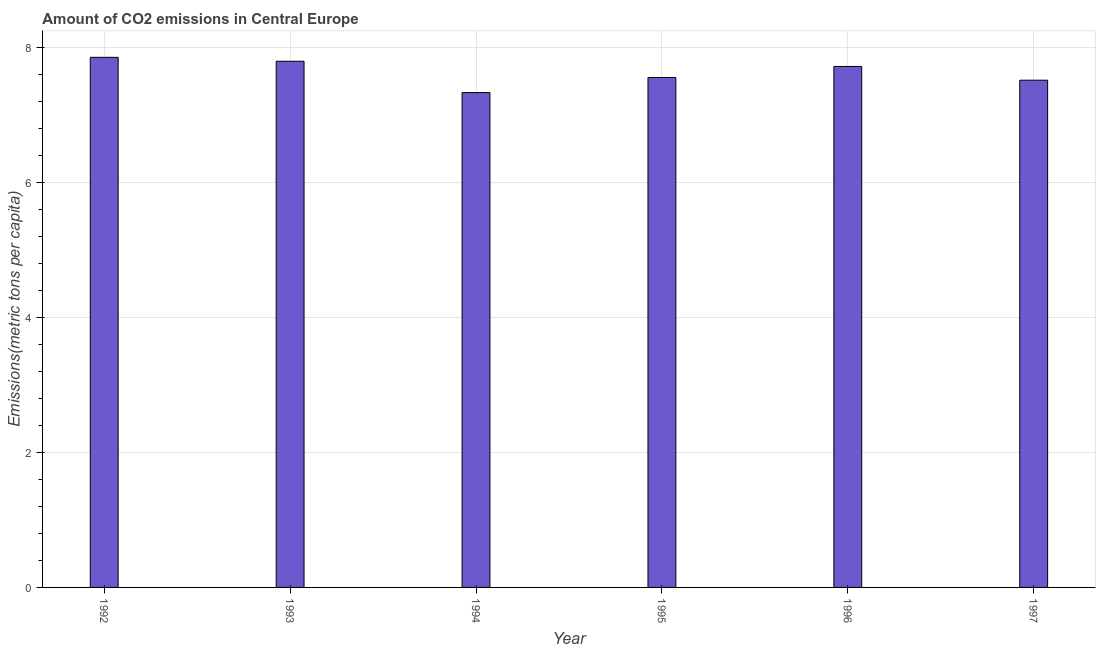Does the graph contain any zero values?
Provide a short and direct response. No. Does the graph contain grids?
Offer a very short reply. Yes. What is the title of the graph?
Your response must be concise. Amount of CO2 emissions in Central Europe. What is the label or title of the Y-axis?
Offer a terse response. Emissions(metric tons per capita). What is the amount of co2 emissions in 1993?
Provide a short and direct response. 7.79. Across all years, what is the maximum amount of co2 emissions?
Provide a succinct answer. 7.85. Across all years, what is the minimum amount of co2 emissions?
Offer a terse response. 7.33. What is the sum of the amount of co2 emissions?
Provide a succinct answer. 45.75. What is the difference between the amount of co2 emissions in 1993 and 1996?
Your answer should be very brief. 0.08. What is the average amount of co2 emissions per year?
Keep it short and to the point. 7.62. What is the median amount of co2 emissions?
Your answer should be very brief. 7.63. In how many years, is the amount of co2 emissions greater than 7.2 metric tons per capita?
Provide a short and direct response. 6. What is the ratio of the amount of co2 emissions in 1994 to that in 1995?
Provide a succinct answer. 0.97. Is the difference between the amount of co2 emissions in 1994 and 1995 greater than the difference between any two years?
Give a very brief answer. No. What is the difference between the highest and the second highest amount of co2 emissions?
Keep it short and to the point. 0.06. What is the difference between the highest and the lowest amount of co2 emissions?
Your answer should be very brief. 0.52. In how many years, is the amount of co2 emissions greater than the average amount of co2 emissions taken over all years?
Make the answer very short. 3. How many bars are there?
Keep it short and to the point. 6. How many years are there in the graph?
Offer a very short reply. 6. Are the values on the major ticks of Y-axis written in scientific E-notation?
Keep it short and to the point. No. What is the Emissions(metric tons per capita) of 1992?
Your answer should be very brief. 7.85. What is the Emissions(metric tons per capita) in 1993?
Your answer should be very brief. 7.79. What is the Emissions(metric tons per capita) in 1994?
Ensure brevity in your answer.  7.33. What is the Emissions(metric tons per capita) of 1995?
Offer a very short reply. 7.55. What is the Emissions(metric tons per capita) of 1996?
Keep it short and to the point. 7.72. What is the Emissions(metric tons per capita) of 1997?
Your answer should be very brief. 7.51. What is the difference between the Emissions(metric tons per capita) in 1992 and 1993?
Offer a terse response. 0.06. What is the difference between the Emissions(metric tons per capita) in 1992 and 1994?
Offer a very short reply. 0.52. What is the difference between the Emissions(metric tons per capita) in 1992 and 1995?
Provide a short and direct response. 0.3. What is the difference between the Emissions(metric tons per capita) in 1992 and 1996?
Offer a very short reply. 0.14. What is the difference between the Emissions(metric tons per capita) in 1992 and 1997?
Your answer should be very brief. 0.34. What is the difference between the Emissions(metric tons per capita) in 1993 and 1994?
Your answer should be very brief. 0.46. What is the difference between the Emissions(metric tons per capita) in 1993 and 1995?
Your answer should be compact. 0.24. What is the difference between the Emissions(metric tons per capita) in 1993 and 1996?
Make the answer very short. 0.08. What is the difference between the Emissions(metric tons per capita) in 1993 and 1997?
Ensure brevity in your answer.  0.28. What is the difference between the Emissions(metric tons per capita) in 1994 and 1995?
Your answer should be very brief. -0.22. What is the difference between the Emissions(metric tons per capita) in 1994 and 1996?
Offer a very short reply. -0.39. What is the difference between the Emissions(metric tons per capita) in 1994 and 1997?
Your response must be concise. -0.18. What is the difference between the Emissions(metric tons per capita) in 1995 and 1996?
Your answer should be very brief. -0.16. What is the difference between the Emissions(metric tons per capita) in 1995 and 1997?
Your response must be concise. 0.04. What is the difference between the Emissions(metric tons per capita) in 1996 and 1997?
Ensure brevity in your answer.  0.2. What is the ratio of the Emissions(metric tons per capita) in 1992 to that in 1994?
Offer a terse response. 1.07. What is the ratio of the Emissions(metric tons per capita) in 1992 to that in 1995?
Provide a succinct answer. 1.04. What is the ratio of the Emissions(metric tons per capita) in 1992 to that in 1996?
Offer a very short reply. 1.02. What is the ratio of the Emissions(metric tons per capita) in 1992 to that in 1997?
Provide a succinct answer. 1.04. What is the ratio of the Emissions(metric tons per capita) in 1993 to that in 1994?
Offer a terse response. 1.06. What is the ratio of the Emissions(metric tons per capita) in 1993 to that in 1995?
Your answer should be compact. 1.03. What is the ratio of the Emissions(metric tons per capita) in 1993 to that in 1996?
Make the answer very short. 1.01. What is the ratio of the Emissions(metric tons per capita) in 1994 to that in 1995?
Your answer should be compact. 0.97. What is the ratio of the Emissions(metric tons per capita) in 1995 to that in 1997?
Your answer should be very brief. 1. What is the ratio of the Emissions(metric tons per capita) in 1996 to that in 1997?
Your response must be concise. 1.03. 